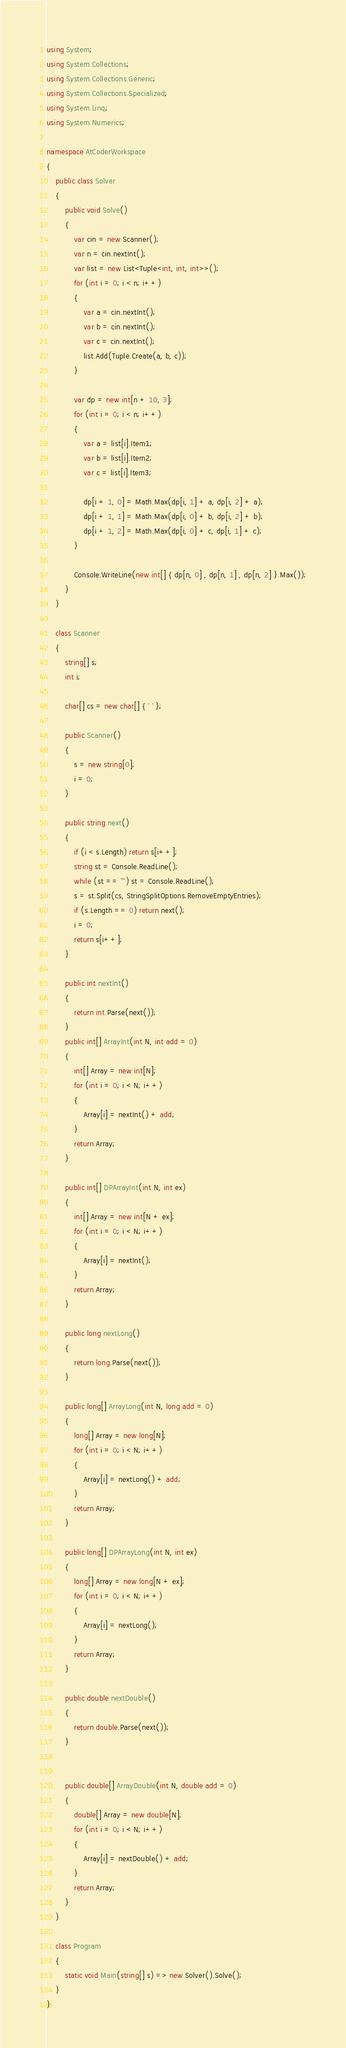Convert code to text. <code><loc_0><loc_0><loc_500><loc_500><_C#_>using System;
using System.Collections;
using System.Collections.Generic;
using System.Collections.Specialized;
using System.Linq;
using System.Numerics;

namespace AtCoderWorkspace
{
    public class Solver
    {
        public void Solve()
        {
            var cin = new Scanner();
            var n = cin.nextInt();
            var list = new List<Tuple<int, int, int>>();
            for (int i = 0; i < n; i++)
            {
                var a = cin.nextInt();
                var b = cin.nextInt();
                var c = cin.nextInt();
                list.Add(Tuple.Create(a, b, c));
            }

            var dp = new int[n + 10, 3];
            for (int i = 0; i < n; i++)
            {
                var a = list[i].Item1;
                var b = list[i].Item2;
                var c = list[i].Item3;

                dp[i + 1, 0] = Math.Max(dp[i, 1] + a, dp[i, 2] + a);
                dp[i + 1, 1] = Math.Max(dp[i, 0] + b, dp[i, 2] + b);
                dp[i + 1, 2] = Math.Max(dp[i, 0] + c, dp[i, 1] + c);
            }

            Console.WriteLine(new int[] { dp[n, 0] , dp[n, 1] , dp[n, 2] }.Max());
        }
    }

    class Scanner
    {
        string[] s;
        int i;

        char[] cs = new char[] { ' ' };

        public Scanner()
        {
            s = new string[0];
            i = 0;
        }

        public string next()
        {
            if (i < s.Length) return s[i++];
            string st = Console.ReadLine();
            while (st == "") st = Console.ReadLine();
            s = st.Split(cs, StringSplitOptions.RemoveEmptyEntries);
            if (s.Length == 0) return next();
            i = 0;
            return s[i++];
        }

        public int nextInt()
        {
            return int.Parse(next());
        }
        public int[] ArrayInt(int N, int add = 0)
        {
            int[] Array = new int[N];
            for (int i = 0; i < N; i++)
            {
                Array[i] = nextInt() + add;
            }
            return Array;
        }

        public int[] DPArrayInt(int N, int ex)
        {
            int[] Array = new int[N + ex];
            for (int i = 0; i < N; i++)
            {
                Array[i] = nextInt();
            }
            return Array;
        }

        public long nextLong()
        {
            return long.Parse(next());
        }

        public long[] ArrayLong(int N, long add = 0)
        {
            long[] Array = new long[N];
            for (int i = 0; i < N; i++)
            {
                Array[i] = nextLong() + add;
            }
            return Array;
        }

        public long[] DPArrayLong(int N, int ex)
        {
            long[] Array = new long[N + ex];
            for (int i = 0; i < N; i++)
            {
                Array[i] = nextLong();
            }
            return Array;
        }

        public double nextDouble()
        {
            return double.Parse(next());
        }


        public double[] ArrayDouble(int N, double add = 0)
        {
            double[] Array = new double[N];
            for (int i = 0; i < N; i++)
            {
                Array[i] = nextDouble() + add;
            }
            return Array;
        }
    }

    class Program
    {
        static void Main(string[] s) => new Solver().Solve();
    }
}
</code> 